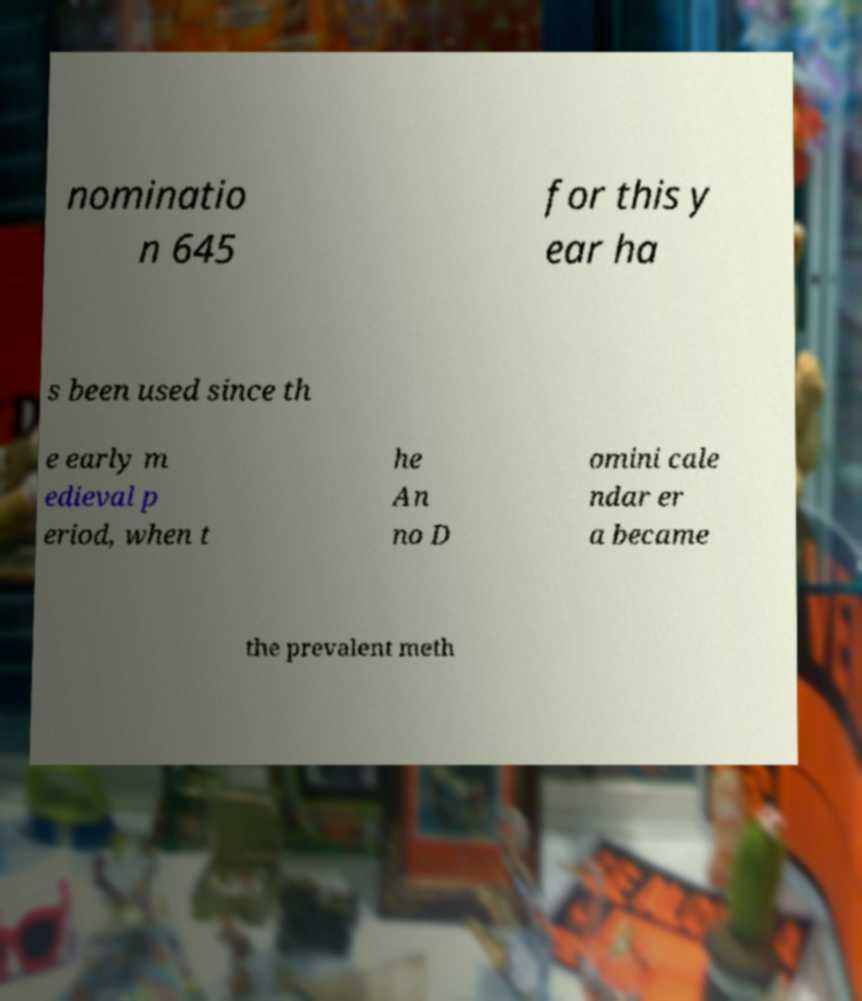Please identify and transcribe the text found in this image. nominatio n 645 for this y ear ha s been used since th e early m edieval p eriod, when t he An no D omini cale ndar er a became the prevalent meth 